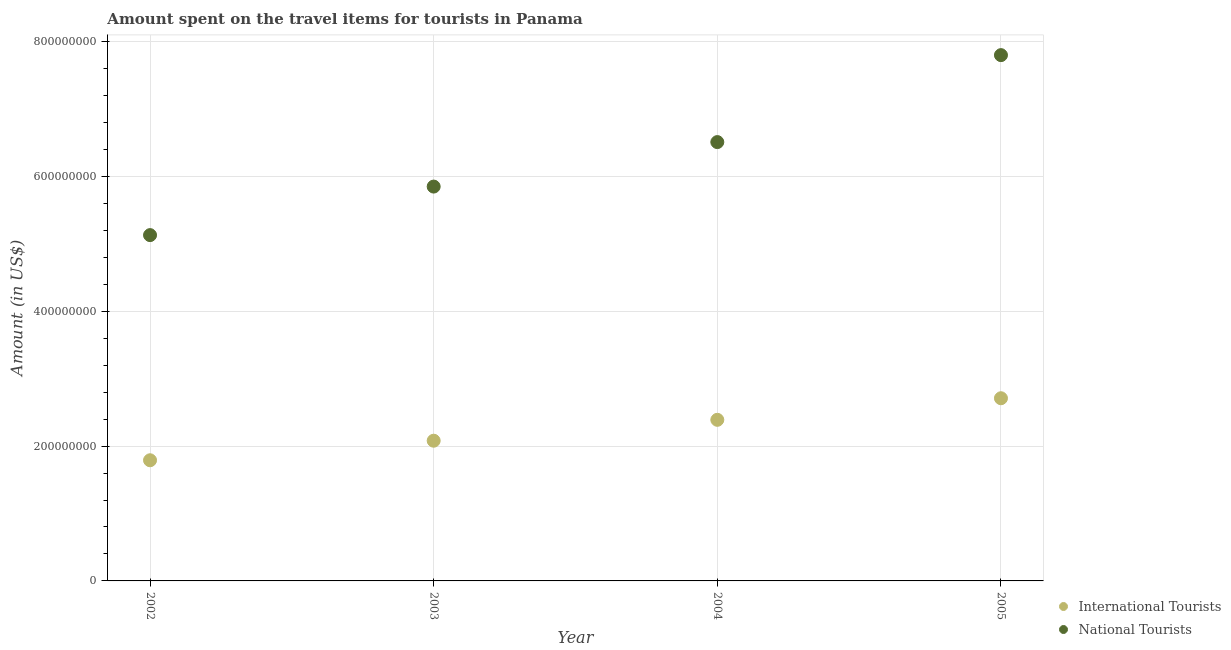How many different coloured dotlines are there?
Provide a short and direct response. 2. What is the amount spent on travel items of international tourists in 2005?
Provide a succinct answer. 2.71e+08. Across all years, what is the maximum amount spent on travel items of international tourists?
Give a very brief answer. 2.71e+08. Across all years, what is the minimum amount spent on travel items of national tourists?
Offer a terse response. 5.13e+08. In which year was the amount spent on travel items of national tourists maximum?
Give a very brief answer. 2005. In which year was the amount spent on travel items of international tourists minimum?
Your answer should be very brief. 2002. What is the total amount spent on travel items of international tourists in the graph?
Keep it short and to the point. 8.97e+08. What is the difference between the amount spent on travel items of national tourists in 2002 and that in 2004?
Make the answer very short. -1.38e+08. What is the difference between the amount spent on travel items of national tourists in 2002 and the amount spent on travel items of international tourists in 2005?
Your answer should be very brief. 2.42e+08. What is the average amount spent on travel items of national tourists per year?
Offer a terse response. 6.32e+08. In the year 2003, what is the difference between the amount spent on travel items of international tourists and amount spent on travel items of national tourists?
Make the answer very short. -3.77e+08. In how many years, is the amount spent on travel items of international tourists greater than 240000000 US$?
Provide a short and direct response. 1. What is the ratio of the amount spent on travel items of national tourists in 2004 to that in 2005?
Keep it short and to the point. 0.83. Is the amount spent on travel items of national tourists in 2003 less than that in 2004?
Offer a terse response. Yes. Is the difference between the amount spent on travel items of national tourists in 2002 and 2005 greater than the difference between the amount spent on travel items of international tourists in 2002 and 2005?
Give a very brief answer. No. What is the difference between the highest and the second highest amount spent on travel items of national tourists?
Give a very brief answer. 1.29e+08. What is the difference between the highest and the lowest amount spent on travel items of international tourists?
Ensure brevity in your answer.  9.20e+07. In how many years, is the amount spent on travel items of international tourists greater than the average amount spent on travel items of international tourists taken over all years?
Your answer should be very brief. 2. Does the amount spent on travel items of international tourists monotonically increase over the years?
Make the answer very short. Yes. Is the amount spent on travel items of national tourists strictly greater than the amount spent on travel items of international tourists over the years?
Keep it short and to the point. Yes. How many dotlines are there?
Your answer should be compact. 2. How many years are there in the graph?
Your response must be concise. 4. Are the values on the major ticks of Y-axis written in scientific E-notation?
Ensure brevity in your answer.  No. Does the graph contain any zero values?
Offer a terse response. No. Where does the legend appear in the graph?
Offer a very short reply. Bottom right. How many legend labels are there?
Make the answer very short. 2. How are the legend labels stacked?
Give a very brief answer. Vertical. What is the title of the graph?
Your answer should be compact. Amount spent on the travel items for tourists in Panama. Does "Techinal cooperation" appear as one of the legend labels in the graph?
Your response must be concise. No. What is the label or title of the X-axis?
Give a very brief answer. Year. What is the Amount (in US$) of International Tourists in 2002?
Give a very brief answer. 1.79e+08. What is the Amount (in US$) of National Tourists in 2002?
Ensure brevity in your answer.  5.13e+08. What is the Amount (in US$) in International Tourists in 2003?
Offer a terse response. 2.08e+08. What is the Amount (in US$) in National Tourists in 2003?
Provide a succinct answer. 5.85e+08. What is the Amount (in US$) of International Tourists in 2004?
Make the answer very short. 2.39e+08. What is the Amount (in US$) in National Tourists in 2004?
Provide a short and direct response. 6.51e+08. What is the Amount (in US$) in International Tourists in 2005?
Your response must be concise. 2.71e+08. What is the Amount (in US$) in National Tourists in 2005?
Your answer should be compact. 7.80e+08. Across all years, what is the maximum Amount (in US$) in International Tourists?
Make the answer very short. 2.71e+08. Across all years, what is the maximum Amount (in US$) of National Tourists?
Offer a terse response. 7.80e+08. Across all years, what is the minimum Amount (in US$) of International Tourists?
Provide a short and direct response. 1.79e+08. Across all years, what is the minimum Amount (in US$) in National Tourists?
Provide a succinct answer. 5.13e+08. What is the total Amount (in US$) of International Tourists in the graph?
Offer a terse response. 8.97e+08. What is the total Amount (in US$) in National Tourists in the graph?
Your response must be concise. 2.53e+09. What is the difference between the Amount (in US$) in International Tourists in 2002 and that in 2003?
Give a very brief answer. -2.90e+07. What is the difference between the Amount (in US$) in National Tourists in 2002 and that in 2003?
Keep it short and to the point. -7.20e+07. What is the difference between the Amount (in US$) in International Tourists in 2002 and that in 2004?
Your response must be concise. -6.00e+07. What is the difference between the Amount (in US$) of National Tourists in 2002 and that in 2004?
Ensure brevity in your answer.  -1.38e+08. What is the difference between the Amount (in US$) in International Tourists in 2002 and that in 2005?
Offer a very short reply. -9.20e+07. What is the difference between the Amount (in US$) in National Tourists in 2002 and that in 2005?
Your response must be concise. -2.67e+08. What is the difference between the Amount (in US$) in International Tourists in 2003 and that in 2004?
Offer a terse response. -3.10e+07. What is the difference between the Amount (in US$) of National Tourists in 2003 and that in 2004?
Your response must be concise. -6.60e+07. What is the difference between the Amount (in US$) of International Tourists in 2003 and that in 2005?
Provide a short and direct response. -6.30e+07. What is the difference between the Amount (in US$) of National Tourists in 2003 and that in 2005?
Give a very brief answer. -1.95e+08. What is the difference between the Amount (in US$) of International Tourists in 2004 and that in 2005?
Your answer should be very brief. -3.20e+07. What is the difference between the Amount (in US$) of National Tourists in 2004 and that in 2005?
Your answer should be very brief. -1.29e+08. What is the difference between the Amount (in US$) of International Tourists in 2002 and the Amount (in US$) of National Tourists in 2003?
Provide a succinct answer. -4.06e+08. What is the difference between the Amount (in US$) in International Tourists in 2002 and the Amount (in US$) in National Tourists in 2004?
Your answer should be very brief. -4.72e+08. What is the difference between the Amount (in US$) in International Tourists in 2002 and the Amount (in US$) in National Tourists in 2005?
Your response must be concise. -6.01e+08. What is the difference between the Amount (in US$) in International Tourists in 2003 and the Amount (in US$) in National Tourists in 2004?
Offer a very short reply. -4.43e+08. What is the difference between the Amount (in US$) of International Tourists in 2003 and the Amount (in US$) of National Tourists in 2005?
Provide a succinct answer. -5.72e+08. What is the difference between the Amount (in US$) in International Tourists in 2004 and the Amount (in US$) in National Tourists in 2005?
Your answer should be very brief. -5.41e+08. What is the average Amount (in US$) of International Tourists per year?
Your response must be concise. 2.24e+08. What is the average Amount (in US$) in National Tourists per year?
Ensure brevity in your answer.  6.32e+08. In the year 2002, what is the difference between the Amount (in US$) in International Tourists and Amount (in US$) in National Tourists?
Provide a succinct answer. -3.34e+08. In the year 2003, what is the difference between the Amount (in US$) in International Tourists and Amount (in US$) in National Tourists?
Give a very brief answer. -3.77e+08. In the year 2004, what is the difference between the Amount (in US$) in International Tourists and Amount (in US$) in National Tourists?
Your answer should be compact. -4.12e+08. In the year 2005, what is the difference between the Amount (in US$) in International Tourists and Amount (in US$) in National Tourists?
Ensure brevity in your answer.  -5.09e+08. What is the ratio of the Amount (in US$) of International Tourists in 2002 to that in 2003?
Provide a succinct answer. 0.86. What is the ratio of the Amount (in US$) of National Tourists in 2002 to that in 2003?
Offer a very short reply. 0.88. What is the ratio of the Amount (in US$) in International Tourists in 2002 to that in 2004?
Offer a very short reply. 0.75. What is the ratio of the Amount (in US$) in National Tourists in 2002 to that in 2004?
Your response must be concise. 0.79. What is the ratio of the Amount (in US$) in International Tourists in 2002 to that in 2005?
Offer a terse response. 0.66. What is the ratio of the Amount (in US$) in National Tourists in 2002 to that in 2005?
Ensure brevity in your answer.  0.66. What is the ratio of the Amount (in US$) of International Tourists in 2003 to that in 2004?
Keep it short and to the point. 0.87. What is the ratio of the Amount (in US$) in National Tourists in 2003 to that in 2004?
Your answer should be very brief. 0.9. What is the ratio of the Amount (in US$) of International Tourists in 2003 to that in 2005?
Your answer should be compact. 0.77. What is the ratio of the Amount (in US$) of National Tourists in 2003 to that in 2005?
Ensure brevity in your answer.  0.75. What is the ratio of the Amount (in US$) of International Tourists in 2004 to that in 2005?
Keep it short and to the point. 0.88. What is the ratio of the Amount (in US$) in National Tourists in 2004 to that in 2005?
Offer a very short reply. 0.83. What is the difference between the highest and the second highest Amount (in US$) of International Tourists?
Give a very brief answer. 3.20e+07. What is the difference between the highest and the second highest Amount (in US$) of National Tourists?
Offer a terse response. 1.29e+08. What is the difference between the highest and the lowest Amount (in US$) of International Tourists?
Provide a short and direct response. 9.20e+07. What is the difference between the highest and the lowest Amount (in US$) of National Tourists?
Keep it short and to the point. 2.67e+08. 